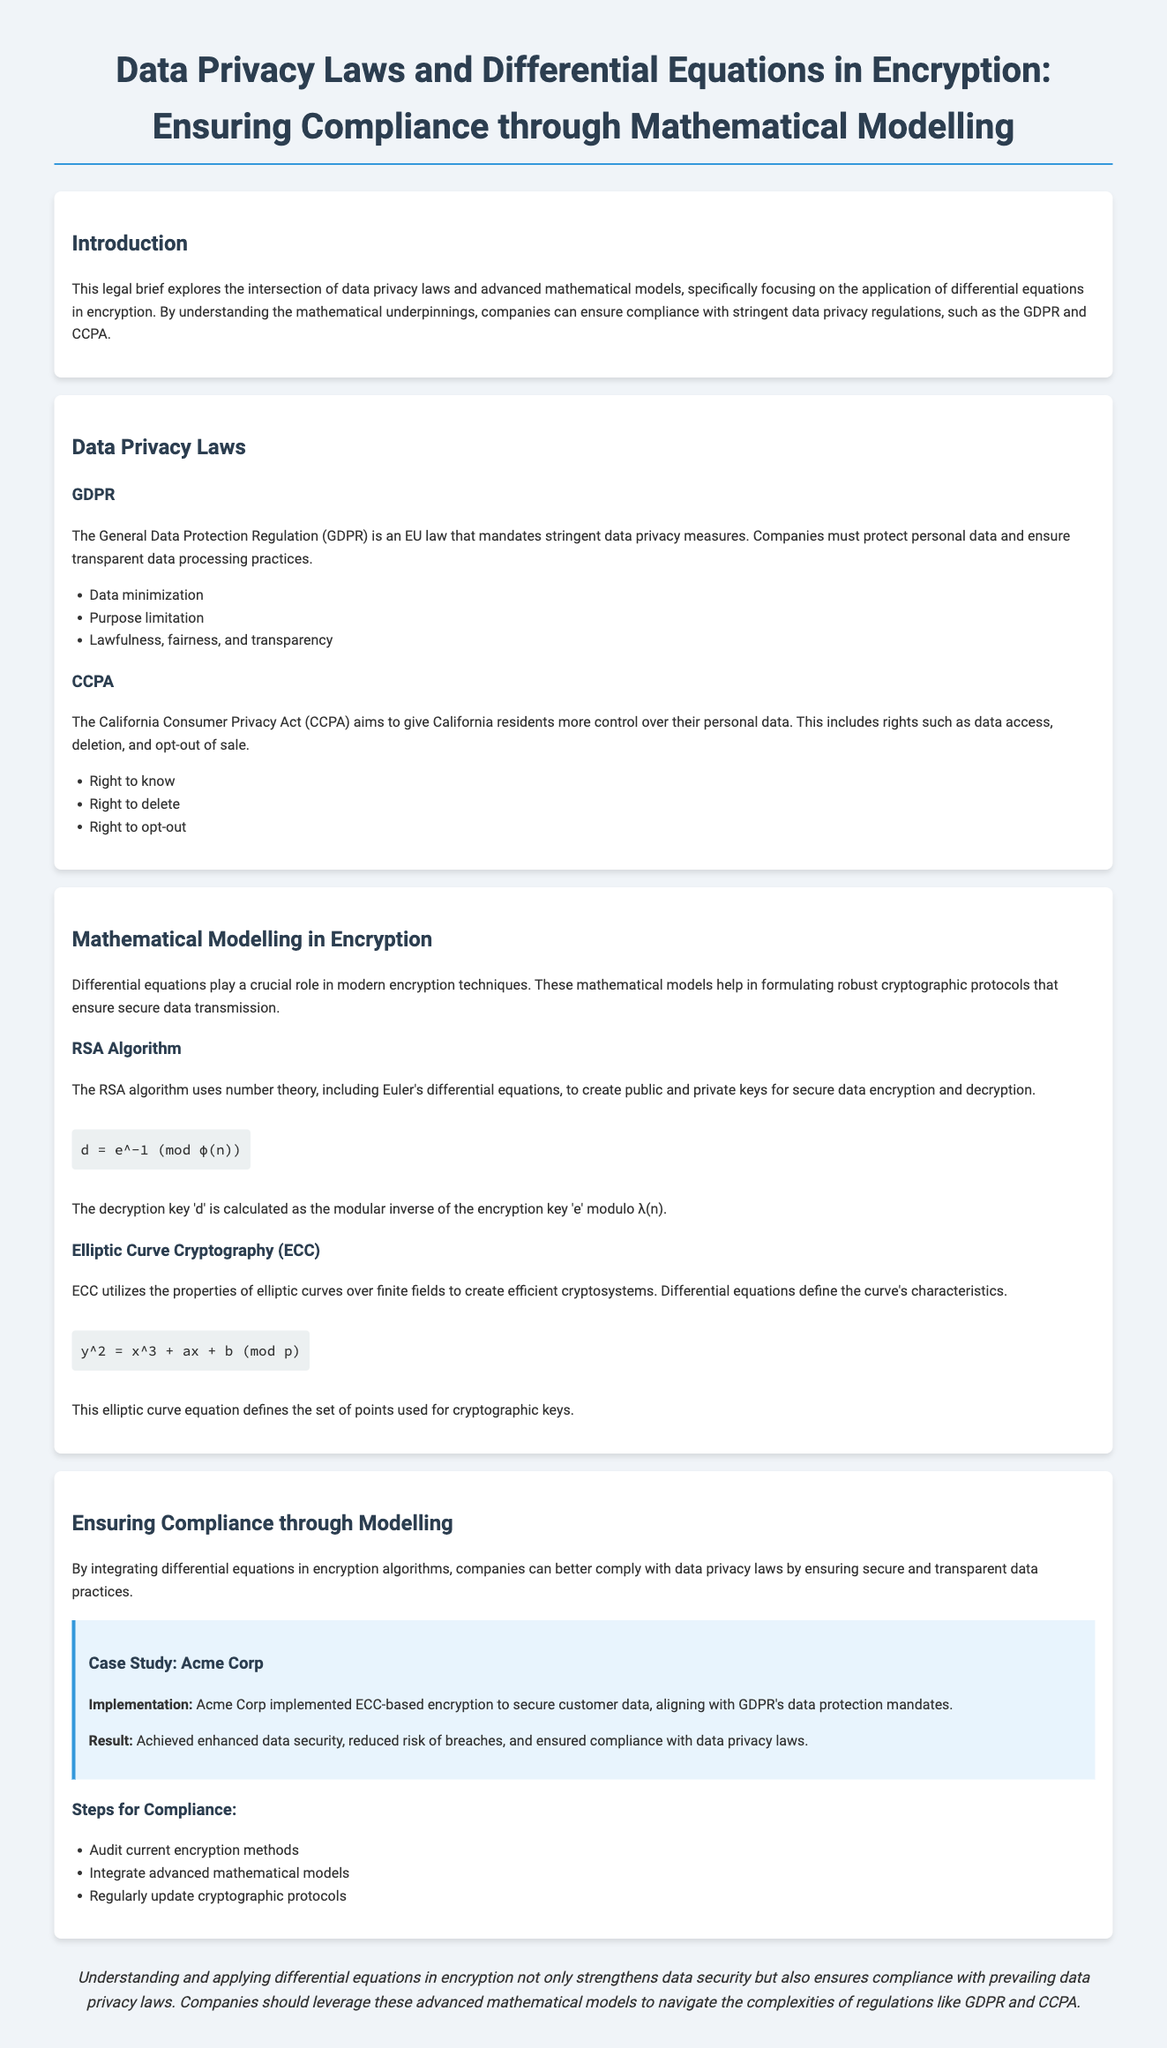What are the two key data privacy laws discussed? The document mentions two laws: the General Data Protection Regulation and the California Consumer Privacy Act.
Answer: GDPR and CCPA What does GDPR stand for? GDPR is an abbreviation for General Data Protection Regulation, which is an EU law for data privacy.
Answer: General Data Protection Regulation What is the primary role of differential equations in encryption? The document states that differential equations help in formulating robust cryptographic protocols for secure data transmission.
Answer: Cryptographic protocols What does the elliptic curve equation represent? The equation y² = x³ + ax + b (mod p) defines the set of points used for cryptographic keys in ECC.
Answer: Cryptographic keys What does the result of Acme Corp's implementation illustrate? The case study illustrates enhanced data security and compliance with data privacy laws following the use of ECC-based encryption.
Answer: Enhanced data security How many steps are listed for compliance in the document? The document highlights three steps that companies should follow to ensure compliance with data privacy laws.
Answer: Three steps What is the encryption method mentioned as part of the case study? The case study specifically mentions the use of ECC-based encryption by Acme Corp to secure customer data.
Answer: ECC-based encryption What is one right provided under the CCPA? The document outlines several rights under the CCPA, including the right to know about personal data collection.
Answer: Right to know 